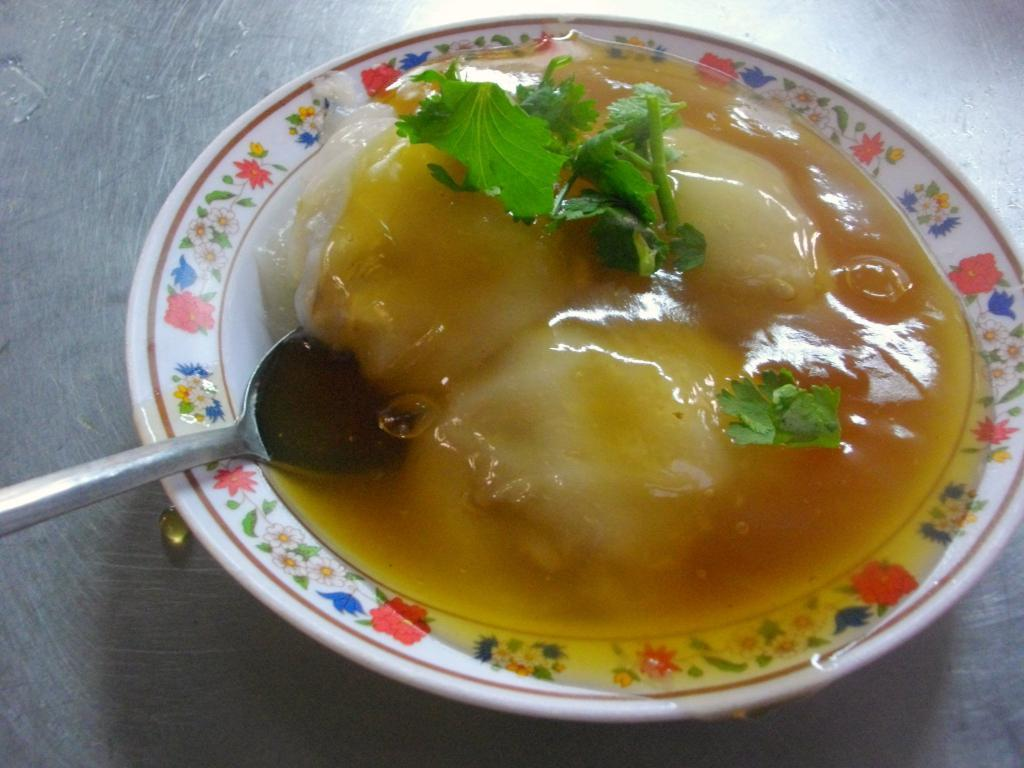What is on the plate in the image? There are leaves, a spoon, honey, and other food items on the plate. What color is the plate? The plate is white in color. Where is the plate located in the image? The plate is placed on a surface. What is the background color of the image? The background of the image is gray. How does the kitty feel about the honey on the plate? There is no kitty present in the image, so it is not possible to determine how a kitty might feel about the honey on the plate. 